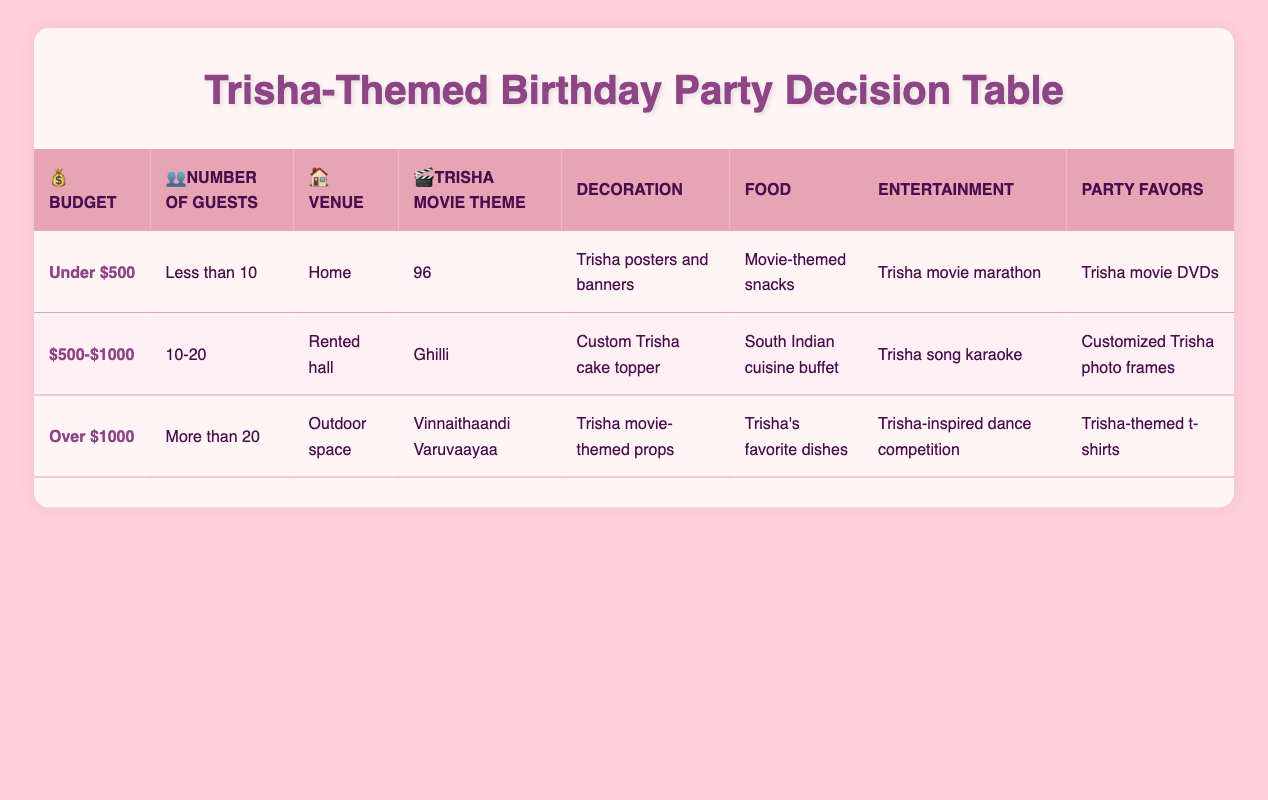What decorations are listed for a party with a budget of under $500? From the table, the decoration option for a budget of under $500 is "Trisha posters and banners." I located the row corresponding to this budget and noted the decoration option related to it.
Answer: Trisha posters and banners What type of food is suggested for a party with 10-20 guests in a rented hall? The table indicates that for a budget of $500-$1000, with 10-20 guests at a rented hall, the food option is "South Indian cuisine buffet." This was found by examining the relevant row for this condition.
Answer: South Indian cuisine buffet Is "Trisha song karaoke" listed as an entertainment option for parties with more than 20 guests? The table shows that "Trisha song karaoke" is not listed for parties with more than 20 guests; instead, the entertainment option is "Trisha-inspired dance competition." This information is directly checked against the row for this condition.
Answer: No How many different decoration options are available for a budget of over $1000? We check the row for over $1000 and find that the decoration option is "Trisha movie-themed props." Since there is only one decoration option provided in this row, there is just one.
Answer: 1 What food option is associated with the Vinnaithaandi Varuvaayaa movie theme? According to the table, for the movie theme "Vinnaithaandi Varuvaayaa" and a budget of over $1000, the food option is "Trisha's favorite dishes." I derived this information directly from the pertinent row for that movie theme.
Answer: Trisha's favorite dishes If a party has a budget of $500-$1000 and less than 10 guests, what are the entertainment options? The table does not provide a row for a budget of $500-$1000 with less than 10 guests. Therefore, there are no entertainment options listed for this combination. I verified this by looking for a matching condition but found none.
Answer: None Which party favors are suggested for a home party with the theme 96? For the conditions of a home party with the movie theme "96" under the budget of under $500 and less than 10 guests, the table lists "Trisha movie DVDs" as the party favor. This was extracted directly from the corresponding row in the table.
Answer: Trisha movie DVDs What is the average number of guests considered across all three budget ranges? The conditions provide three distinct guest ranges: less than 10, 10-20, and more than 20. We can convert these into numerical values (let's consider them as 5, 15, and 25 respectively) to compute the average as (5 + 15 + 25) / 3 = 15. This involves summing the representative guest numbers and then dividing by the count of options.
Answer: 15 